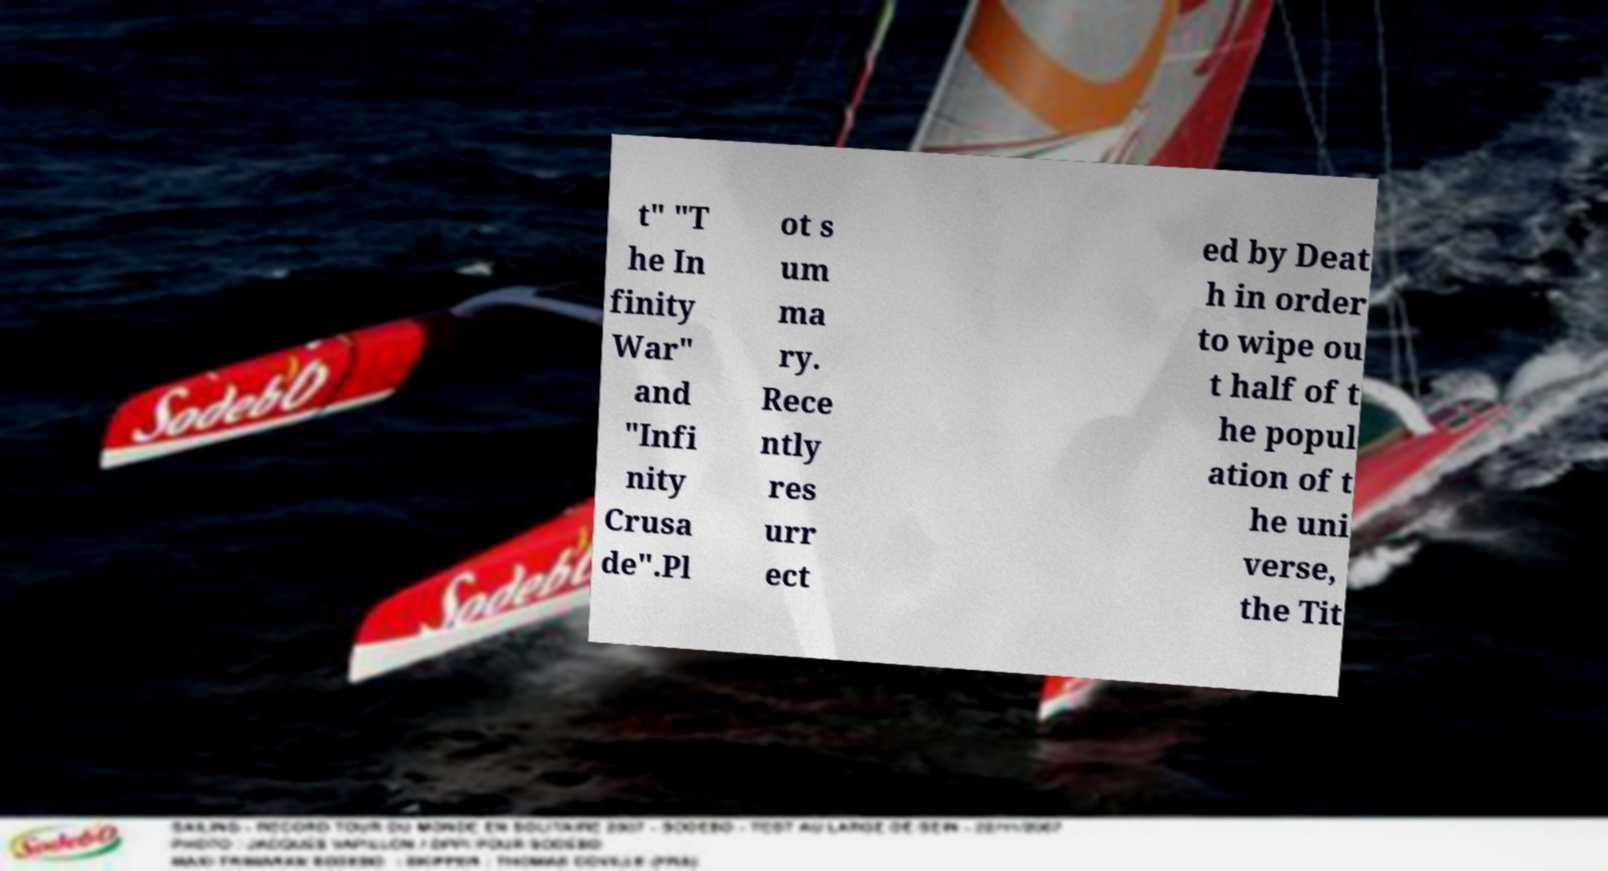I need the written content from this picture converted into text. Can you do that? t" "T he In finity War" and "Infi nity Crusa de".Pl ot s um ma ry. Rece ntly res urr ect ed by Deat h in order to wipe ou t half of t he popul ation of t he uni verse, the Tit 